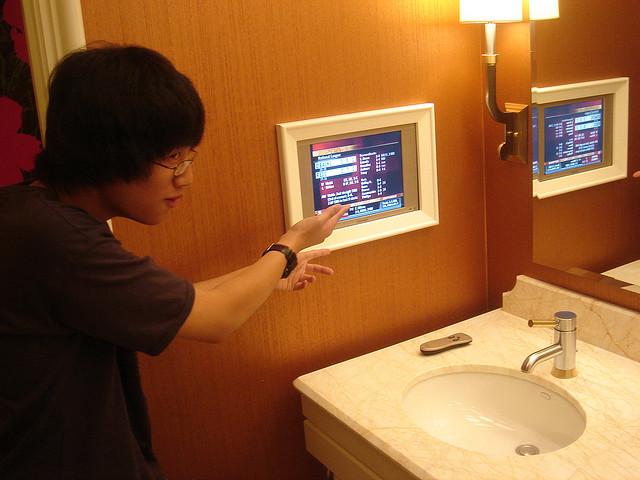What room is this?
Answer briefly. Bathroom. Are there personal items on the sink?
Keep it brief. No. What is on the man's face?
Write a very short answer. Glasses. 